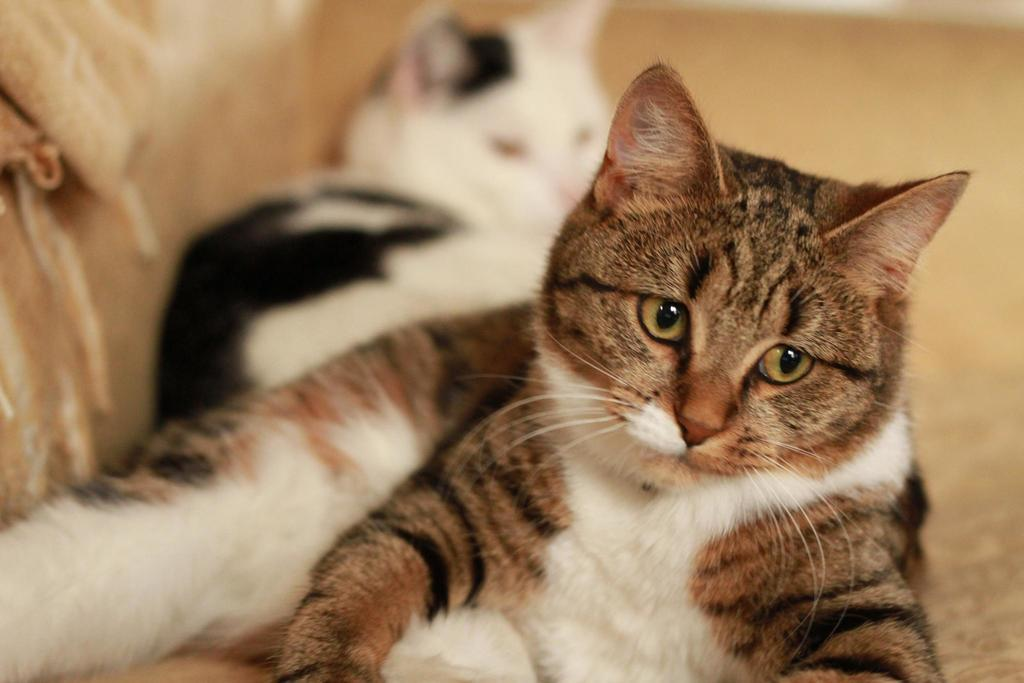How many cats are present in the image? There are two cats in the image. What are the cats doing in the image? The cats are lying on a couch. What type of office furniture is on fire in the image? There is no office furniture or fire present in the image; it features two cats lying on a couch. 